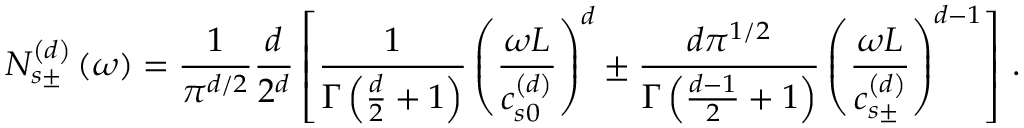<formula> <loc_0><loc_0><loc_500><loc_500>N _ { s \pm } ^ { \left ( d \right ) } \left ( \omega \right ) = \frac { 1 } { \pi ^ { d / 2 } } \frac { d } { 2 ^ { d } } \left [ \frac { 1 } { \Gamma \left ( \frac { d } { 2 } + 1 \right ) } \left ( \frac { \omega L } { c _ { s 0 } ^ { \left ( d \right ) } } \right ) ^ { d } \pm \frac { d \pi ^ { 1 / 2 } } { \Gamma \left ( \frac { d - 1 } { 2 } + 1 \right ) } \left ( \frac { \omega L } { c _ { s \pm } ^ { \left ( d \right ) } } \right ) ^ { d - 1 } \right ] \, .</formula> 